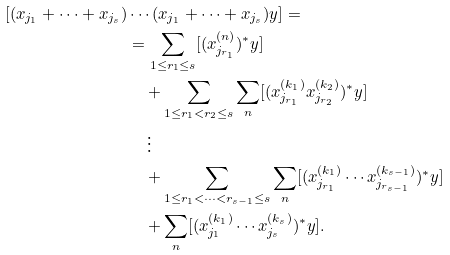Convert formula to latex. <formula><loc_0><loc_0><loc_500><loc_500>[ ( x _ { j _ { 1 } } + \cdots + x _ { j _ { s } } ) & \cdots ( x _ { j _ { 1 } } + \cdots + x _ { j _ { s } } ) y ] = \\ & = \sum _ { \substack { 1 \leq r _ { 1 } \leq s } } [ ( x _ { j _ { r _ { 1 } } } ^ { ( n ) } ) ^ { \ast } y ] \\ & \quad + \sum _ { 1 \leq r _ { 1 } < r _ { 2 } \leq s } \sum _ { n } [ ( x _ { j _ { r _ { 1 } } } ^ { ( k _ { 1 } ) } x _ { j _ { r _ { 2 } } } ^ { ( k _ { 2 } ) } ) ^ { \ast } y ] \\ & \quad \, \vdots \\ & \quad + \sum _ { 1 \leq r _ { 1 } < \cdots < r _ { s - 1 } \leq s } \sum _ { n } [ ( x _ { j _ { r _ { 1 } } } ^ { ( k _ { 1 } ) } \cdots x _ { j _ { r _ { s - 1 } } } ^ { ( k _ { s - 1 } ) } ) ^ { \ast } y ] \\ & \quad + \sum _ { n } [ ( x _ { j _ { 1 } } ^ { ( k _ { 1 } ) } \cdots x _ { j _ { s } } ^ { ( k _ { s } ) } ) ^ { \ast } y ] .</formula> 